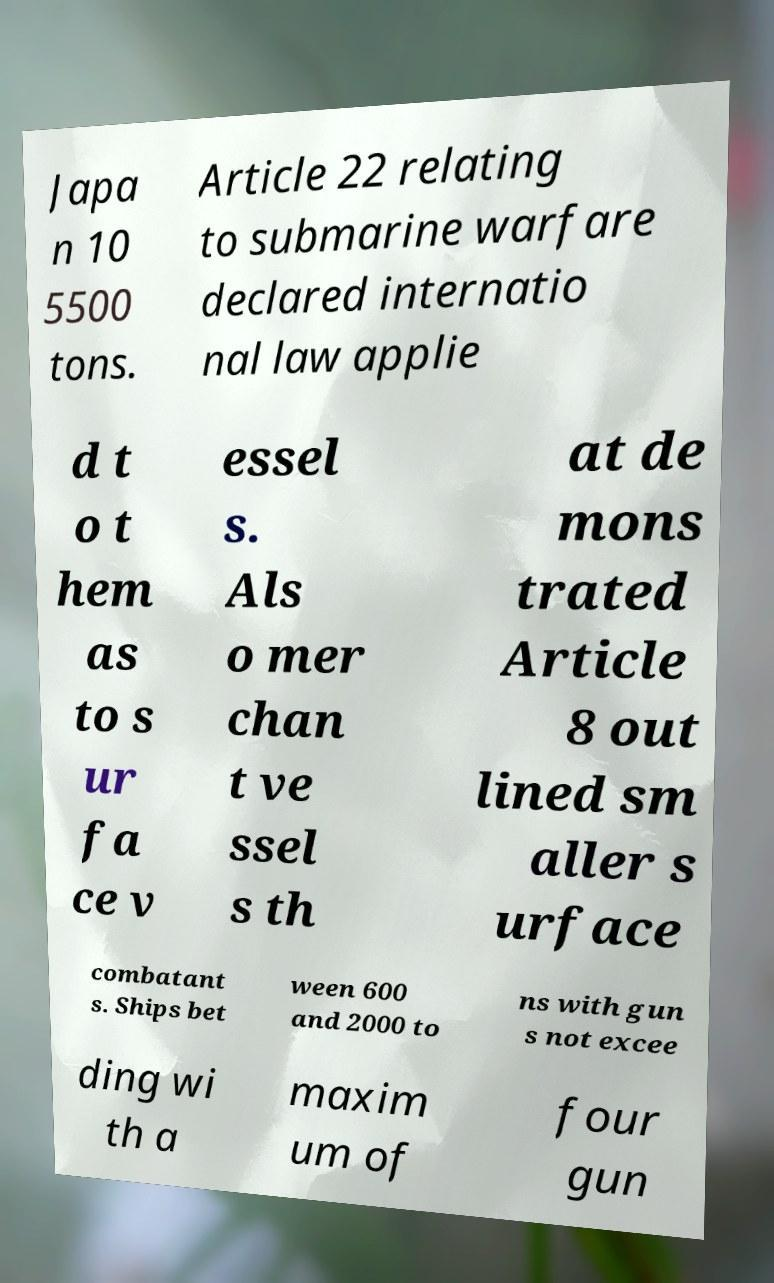There's text embedded in this image that I need extracted. Can you transcribe it verbatim? Japa n 10 5500 tons. Article 22 relating to submarine warfare declared internatio nal law applie d t o t hem as to s ur fa ce v essel s. Als o mer chan t ve ssel s th at de mons trated Article 8 out lined sm aller s urface combatant s. Ships bet ween 600 and 2000 to ns with gun s not excee ding wi th a maxim um of four gun 